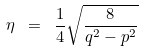Convert formula to latex. <formula><loc_0><loc_0><loc_500><loc_500>\eta \ = \ \frac { 1 } { 4 } \sqrt { \frac { 8 } { q ^ { 2 } - p ^ { 2 } } }</formula> 